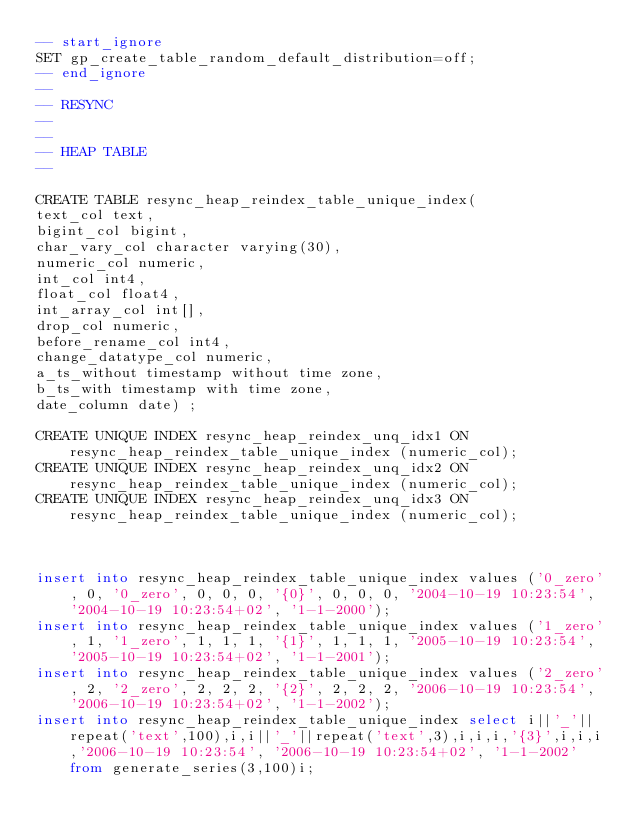Convert code to text. <code><loc_0><loc_0><loc_500><loc_500><_SQL_>-- start_ignore
SET gp_create_table_random_default_distribution=off;
-- end_ignore
--
-- RESYNC
--
--
-- HEAP TABLE
--

CREATE TABLE resync_heap_reindex_table_unique_index(
text_col text,
bigint_col bigint,
char_vary_col character varying(30),
numeric_col numeric,
int_col int4,
float_col float4,
int_array_col int[],
drop_col numeric,
before_rename_col int4,
change_datatype_col numeric,
a_ts_without timestamp without time zone,
b_ts_with timestamp with time zone,
date_column date) ;

CREATE UNIQUE INDEX resync_heap_reindex_unq_idx1 ON resync_heap_reindex_table_unique_index (numeric_col);
CREATE UNIQUE INDEX resync_heap_reindex_unq_idx2 ON resync_heap_reindex_table_unique_index (numeric_col);
CREATE UNIQUE INDEX resync_heap_reindex_unq_idx3 ON resync_heap_reindex_table_unique_index (numeric_col);



insert into resync_heap_reindex_table_unique_index values ('0_zero', 0, '0_zero', 0, 0, 0, '{0}', 0, 0, 0, '2004-10-19 10:23:54', '2004-10-19 10:23:54+02', '1-1-2000');
insert into resync_heap_reindex_table_unique_index values ('1_zero', 1, '1_zero', 1, 1, 1, '{1}', 1, 1, 1, '2005-10-19 10:23:54', '2005-10-19 10:23:54+02', '1-1-2001');
insert into resync_heap_reindex_table_unique_index values ('2_zero', 2, '2_zero', 2, 2, 2, '{2}', 2, 2, 2, '2006-10-19 10:23:54', '2006-10-19 10:23:54+02', '1-1-2002');
insert into resync_heap_reindex_table_unique_index select i||'_'||repeat('text',100),i,i||'_'||repeat('text',3),i,i,i,'{3}',i,i,i,'2006-10-19 10:23:54', '2006-10-19 10:23:54+02', '1-1-2002' from generate_series(3,100)i;
</code> 